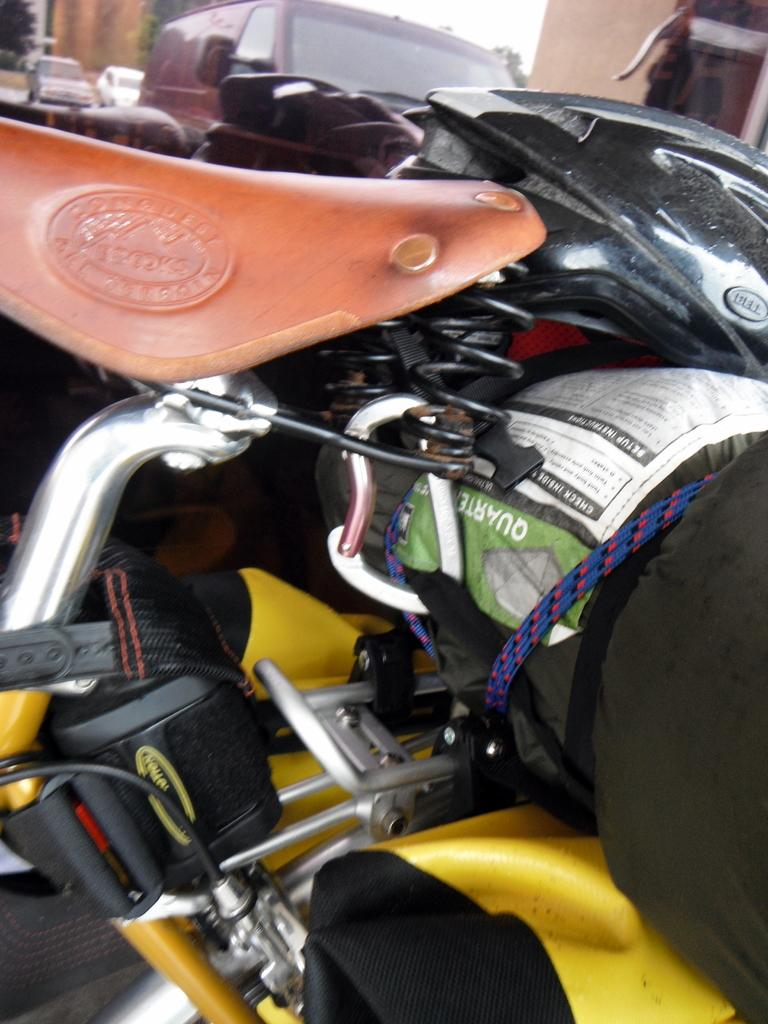What is tied to the bicycle in the image? A cloth is tied to the bicycle. What is on the cloth? A helmet is on the cloth. What can be seen in the background of the image? There are trees, vehicles, a wall, and the sky visible in the background of the image. How many children are playing with the expansion in the image? There are no children or expansion present in the image. 